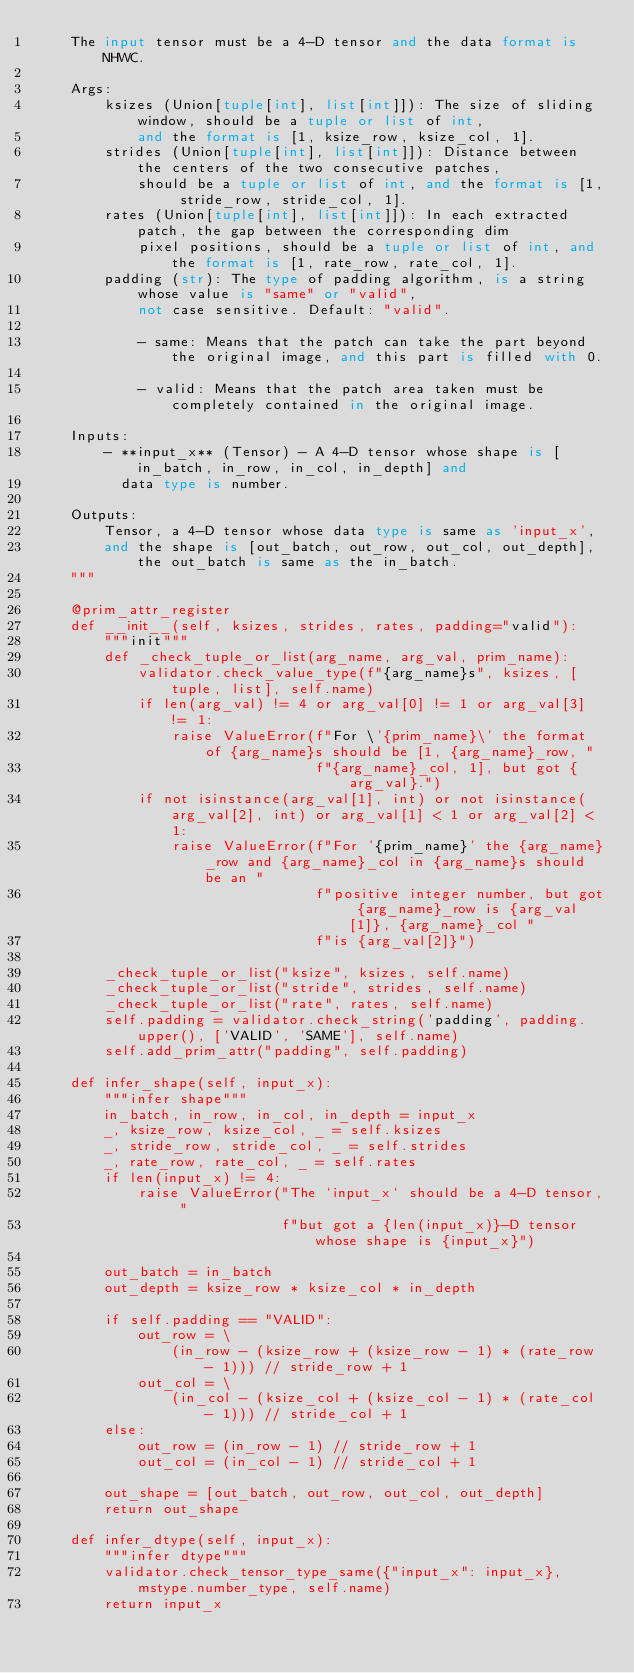Convert code to text. <code><loc_0><loc_0><loc_500><loc_500><_Python_>    The input tensor must be a 4-D tensor and the data format is NHWC.

    Args:
        ksizes (Union[tuple[int], list[int]]): The size of sliding window, should be a tuple or list of int,
            and the format is [1, ksize_row, ksize_col, 1].
        strides (Union[tuple[int], list[int]]): Distance between the centers of the two consecutive patches,
            should be a tuple or list of int, and the format is [1, stride_row, stride_col, 1].
        rates (Union[tuple[int], list[int]]): In each extracted patch, the gap between the corresponding dim
            pixel positions, should be a tuple or list of int, and the format is [1, rate_row, rate_col, 1].
        padding (str): The type of padding algorithm, is a string whose value is "same" or "valid",
            not case sensitive. Default: "valid".

            - same: Means that the patch can take the part beyond the original image, and this part is filled with 0.

            - valid: Means that the patch area taken must be completely contained in the original image.

    Inputs:
        - **input_x** (Tensor) - A 4-D tensor whose shape is [in_batch, in_row, in_col, in_depth] and
          data type is number.

    Outputs:
        Tensor, a 4-D tensor whose data type is same as 'input_x',
        and the shape is [out_batch, out_row, out_col, out_depth], the out_batch is same as the in_batch.
    """

    @prim_attr_register
    def __init__(self, ksizes, strides, rates, padding="valid"):
        """init"""
        def _check_tuple_or_list(arg_name, arg_val, prim_name):
            validator.check_value_type(f"{arg_name}s", ksizes, [tuple, list], self.name)
            if len(arg_val) != 4 or arg_val[0] != 1 or arg_val[3] != 1:
                raise ValueError(f"For \'{prim_name}\' the format of {arg_name}s should be [1, {arg_name}_row, "
                                 f"{arg_name}_col, 1], but got {arg_val}.")
            if not isinstance(arg_val[1], int) or not isinstance(arg_val[2], int) or arg_val[1] < 1 or arg_val[2] < 1:
                raise ValueError(f"For '{prim_name}' the {arg_name}_row and {arg_name}_col in {arg_name}s should be an "
                                 f"positive integer number, but got {arg_name}_row is {arg_val[1]}, {arg_name}_col "
                                 f"is {arg_val[2]}")

        _check_tuple_or_list("ksize", ksizes, self.name)
        _check_tuple_or_list("stride", strides, self.name)
        _check_tuple_or_list("rate", rates, self.name)
        self.padding = validator.check_string('padding', padding.upper(), ['VALID', 'SAME'], self.name)
        self.add_prim_attr("padding", self.padding)

    def infer_shape(self, input_x):
        """infer shape"""
        in_batch, in_row, in_col, in_depth = input_x
        _, ksize_row, ksize_col, _ = self.ksizes
        _, stride_row, stride_col, _ = self.strides
        _, rate_row, rate_col, _ = self.rates
        if len(input_x) != 4:
            raise ValueError("The `input_x` should be a 4-D tensor, "
                             f"but got a {len(input_x)}-D tensor whose shape is {input_x}")

        out_batch = in_batch
        out_depth = ksize_row * ksize_col * in_depth

        if self.padding == "VALID":
            out_row = \
                (in_row - (ksize_row + (ksize_row - 1) * (rate_row - 1))) // stride_row + 1
            out_col = \
                (in_col - (ksize_col + (ksize_col - 1) * (rate_col - 1))) // stride_col + 1
        else:
            out_row = (in_row - 1) // stride_row + 1
            out_col = (in_col - 1) // stride_col + 1

        out_shape = [out_batch, out_row, out_col, out_depth]
        return out_shape

    def infer_dtype(self, input_x):
        """infer dtype"""
        validator.check_tensor_type_same({"input_x": input_x}, mstype.number_type, self.name)
        return input_x
</code> 